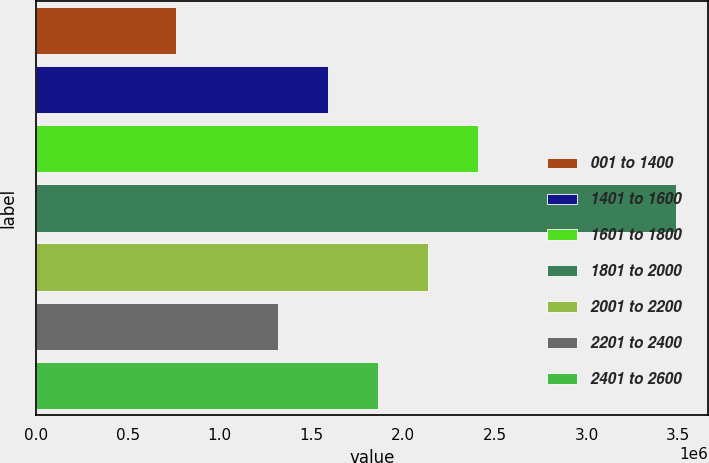<chart> <loc_0><loc_0><loc_500><loc_500><bar_chart><fcel>001 to 1400<fcel>1401 to 1600<fcel>1601 to 1800<fcel>1801 to 2000<fcel>2001 to 2200<fcel>2201 to 2400<fcel>2401 to 2600<nl><fcel>760756<fcel>1.59119e+06<fcel>2.4095e+06<fcel>3.48845e+06<fcel>2.13673e+06<fcel>1.31842e+06<fcel>1.86396e+06<nl></chart> 